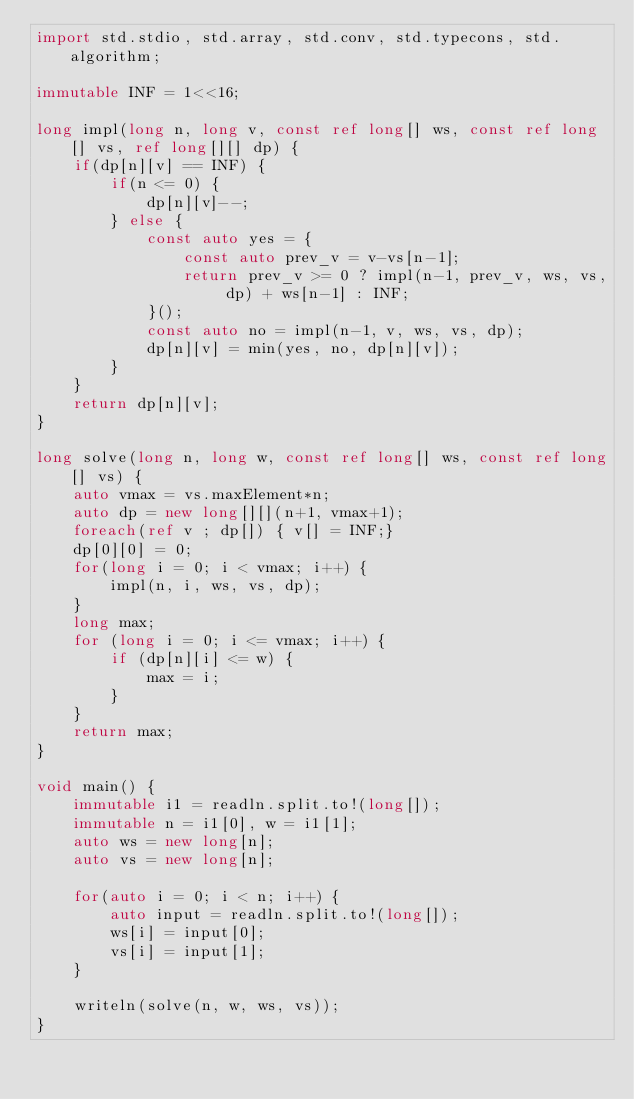Convert code to text. <code><loc_0><loc_0><loc_500><loc_500><_D_>import std.stdio, std.array, std.conv, std.typecons, std.algorithm;

immutable INF = 1<<16;

long impl(long n, long v, const ref long[] ws, const ref long[] vs, ref long[][] dp) {
    if(dp[n][v] == INF) {
        if(n <= 0) {
            dp[n][v]--;
        } else {
            const auto yes = {
                const auto prev_v = v-vs[n-1];
                return prev_v >= 0 ? impl(n-1, prev_v, ws, vs, dp) + ws[n-1] : INF;
            }();
            const auto no = impl(n-1, v, ws, vs, dp);
            dp[n][v] = min(yes, no, dp[n][v]);
        }
    }
    return dp[n][v];
}

long solve(long n, long w, const ref long[] ws, const ref long[] vs) {
    auto vmax = vs.maxElement*n;
    auto dp = new long[][](n+1, vmax+1);
    foreach(ref v ; dp[]) { v[] = INF;}
    dp[0][0] = 0;
    for(long i = 0; i < vmax; i++) {
        impl(n, i, ws, vs, dp);
    }
    long max;
    for (long i = 0; i <= vmax; i++) {
        if (dp[n][i] <= w) {
            max = i;
        }
    }
    return max;
}

void main() {
    immutable i1 = readln.split.to!(long[]);
    immutable n = i1[0], w = i1[1];
    auto ws = new long[n];
    auto vs = new long[n];

    for(auto i = 0; i < n; i++) {
        auto input = readln.split.to!(long[]);
        ws[i] = input[0];
        vs[i] = input[1];
    }

    writeln(solve(n, w, ws, vs));
}
</code> 